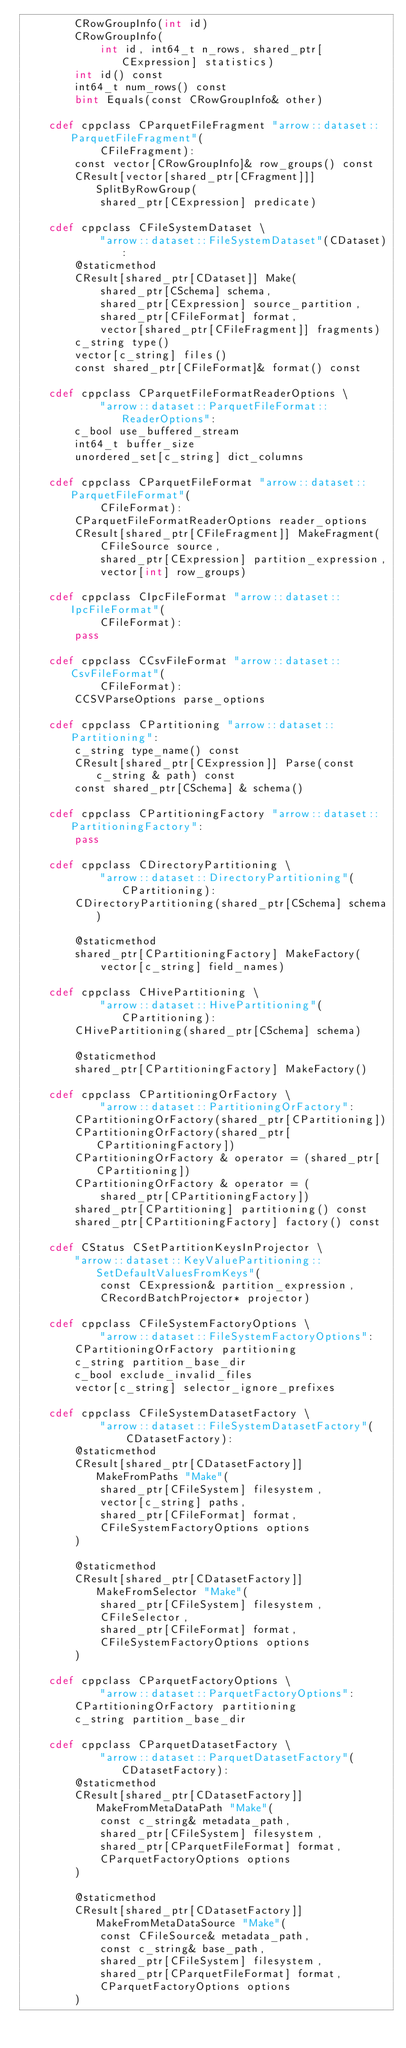Convert code to text. <code><loc_0><loc_0><loc_500><loc_500><_Cython_>        CRowGroupInfo(int id)
        CRowGroupInfo(
            int id, int64_t n_rows, shared_ptr[CExpression] statistics)
        int id() const
        int64_t num_rows() const
        bint Equals(const CRowGroupInfo& other)

    cdef cppclass CParquetFileFragment "arrow::dataset::ParquetFileFragment"(
            CFileFragment):
        const vector[CRowGroupInfo]& row_groups() const
        CResult[vector[shared_ptr[CFragment]]] SplitByRowGroup(
            shared_ptr[CExpression] predicate)

    cdef cppclass CFileSystemDataset \
            "arrow::dataset::FileSystemDataset"(CDataset):
        @staticmethod
        CResult[shared_ptr[CDataset]] Make(
            shared_ptr[CSchema] schema,
            shared_ptr[CExpression] source_partition,
            shared_ptr[CFileFormat] format,
            vector[shared_ptr[CFileFragment]] fragments)
        c_string type()
        vector[c_string] files()
        const shared_ptr[CFileFormat]& format() const

    cdef cppclass CParquetFileFormatReaderOptions \
            "arrow::dataset::ParquetFileFormat::ReaderOptions":
        c_bool use_buffered_stream
        int64_t buffer_size
        unordered_set[c_string] dict_columns

    cdef cppclass CParquetFileFormat "arrow::dataset::ParquetFileFormat"(
            CFileFormat):
        CParquetFileFormatReaderOptions reader_options
        CResult[shared_ptr[CFileFragment]] MakeFragment(
            CFileSource source,
            shared_ptr[CExpression] partition_expression,
            vector[int] row_groups)

    cdef cppclass CIpcFileFormat "arrow::dataset::IpcFileFormat"(
            CFileFormat):
        pass

    cdef cppclass CCsvFileFormat "arrow::dataset::CsvFileFormat"(
            CFileFormat):
        CCSVParseOptions parse_options

    cdef cppclass CPartitioning "arrow::dataset::Partitioning":
        c_string type_name() const
        CResult[shared_ptr[CExpression]] Parse(const c_string & path) const
        const shared_ptr[CSchema] & schema()

    cdef cppclass CPartitioningFactory "arrow::dataset::PartitioningFactory":
        pass

    cdef cppclass CDirectoryPartitioning \
            "arrow::dataset::DirectoryPartitioning"(CPartitioning):
        CDirectoryPartitioning(shared_ptr[CSchema] schema)

        @staticmethod
        shared_ptr[CPartitioningFactory] MakeFactory(
            vector[c_string] field_names)

    cdef cppclass CHivePartitioning \
            "arrow::dataset::HivePartitioning"(CPartitioning):
        CHivePartitioning(shared_ptr[CSchema] schema)

        @staticmethod
        shared_ptr[CPartitioningFactory] MakeFactory()

    cdef cppclass CPartitioningOrFactory \
            "arrow::dataset::PartitioningOrFactory":
        CPartitioningOrFactory(shared_ptr[CPartitioning])
        CPartitioningOrFactory(shared_ptr[CPartitioningFactory])
        CPartitioningOrFactory & operator = (shared_ptr[CPartitioning])
        CPartitioningOrFactory & operator = (
            shared_ptr[CPartitioningFactory])
        shared_ptr[CPartitioning] partitioning() const
        shared_ptr[CPartitioningFactory] factory() const

    cdef CStatus CSetPartitionKeysInProjector \
        "arrow::dataset::KeyValuePartitioning::SetDefaultValuesFromKeys"(
            const CExpression& partition_expression,
            CRecordBatchProjector* projector)

    cdef cppclass CFileSystemFactoryOptions \
            "arrow::dataset::FileSystemFactoryOptions":
        CPartitioningOrFactory partitioning
        c_string partition_base_dir
        c_bool exclude_invalid_files
        vector[c_string] selector_ignore_prefixes

    cdef cppclass CFileSystemDatasetFactory \
            "arrow::dataset::FileSystemDatasetFactory"(
                CDatasetFactory):
        @staticmethod
        CResult[shared_ptr[CDatasetFactory]] MakeFromPaths "Make"(
            shared_ptr[CFileSystem] filesystem,
            vector[c_string] paths,
            shared_ptr[CFileFormat] format,
            CFileSystemFactoryOptions options
        )

        @staticmethod
        CResult[shared_ptr[CDatasetFactory]] MakeFromSelector "Make"(
            shared_ptr[CFileSystem] filesystem,
            CFileSelector,
            shared_ptr[CFileFormat] format,
            CFileSystemFactoryOptions options
        )

    cdef cppclass CParquetFactoryOptions \
            "arrow::dataset::ParquetFactoryOptions":
        CPartitioningOrFactory partitioning
        c_string partition_base_dir

    cdef cppclass CParquetDatasetFactory \
            "arrow::dataset::ParquetDatasetFactory"(CDatasetFactory):
        @staticmethod
        CResult[shared_ptr[CDatasetFactory]] MakeFromMetaDataPath "Make"(
            const c_string& metadata_path,
            shared_ptr[CFileSystem] filesystem,
            shared_ptr[CParquetFileFormat] format,
            CParquetFactoryOptions options
        )

        @staticmethod
        CResult[shared_ptr[CDatasetFactory]] MakeFromMetaDataSource "Make"(
            const CFileSource& metadata_path,
            const c_string& base_path,
            shared_ptr[CFileSystem] filesystem,
            shared_ptr[CParquetFileFormat] format,
            CParquetFactoryOptions options
        )
</code> 